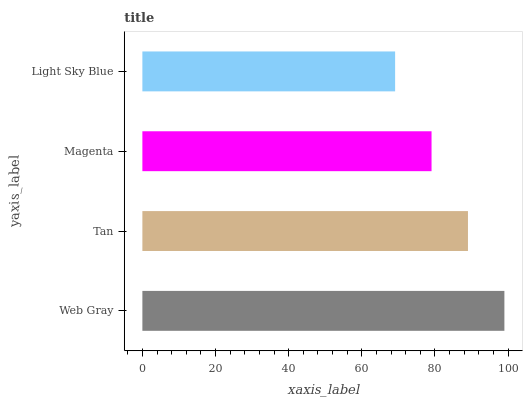Is Light Sky Blue the minimum?
Answer yes or no. Yes. Is Web Gray the maximum?
Answer yes or no. Yes. Is Tan the minimum?
Answer yes or no. No. Is Tan the maximum?
Answer yes or no. No. Is Web Gray greater than Tan?
Answer yes or no. Yes. Is Tan less than Web Gray?
Answer yes or no. Yes. Is Tan greater than Web Gray?
Answer yes or no. No. Is Web Gray less than Tan?
Answer yes or no. No. Is Tan the high median?
Answer yes or no. Yes. Is Magenta the low median?
Answer yes or no. Yes. Is Magenta the high median?
Answer yes or no. No. Is Light Sky Blue the low median?
Answer yes or no. No. 